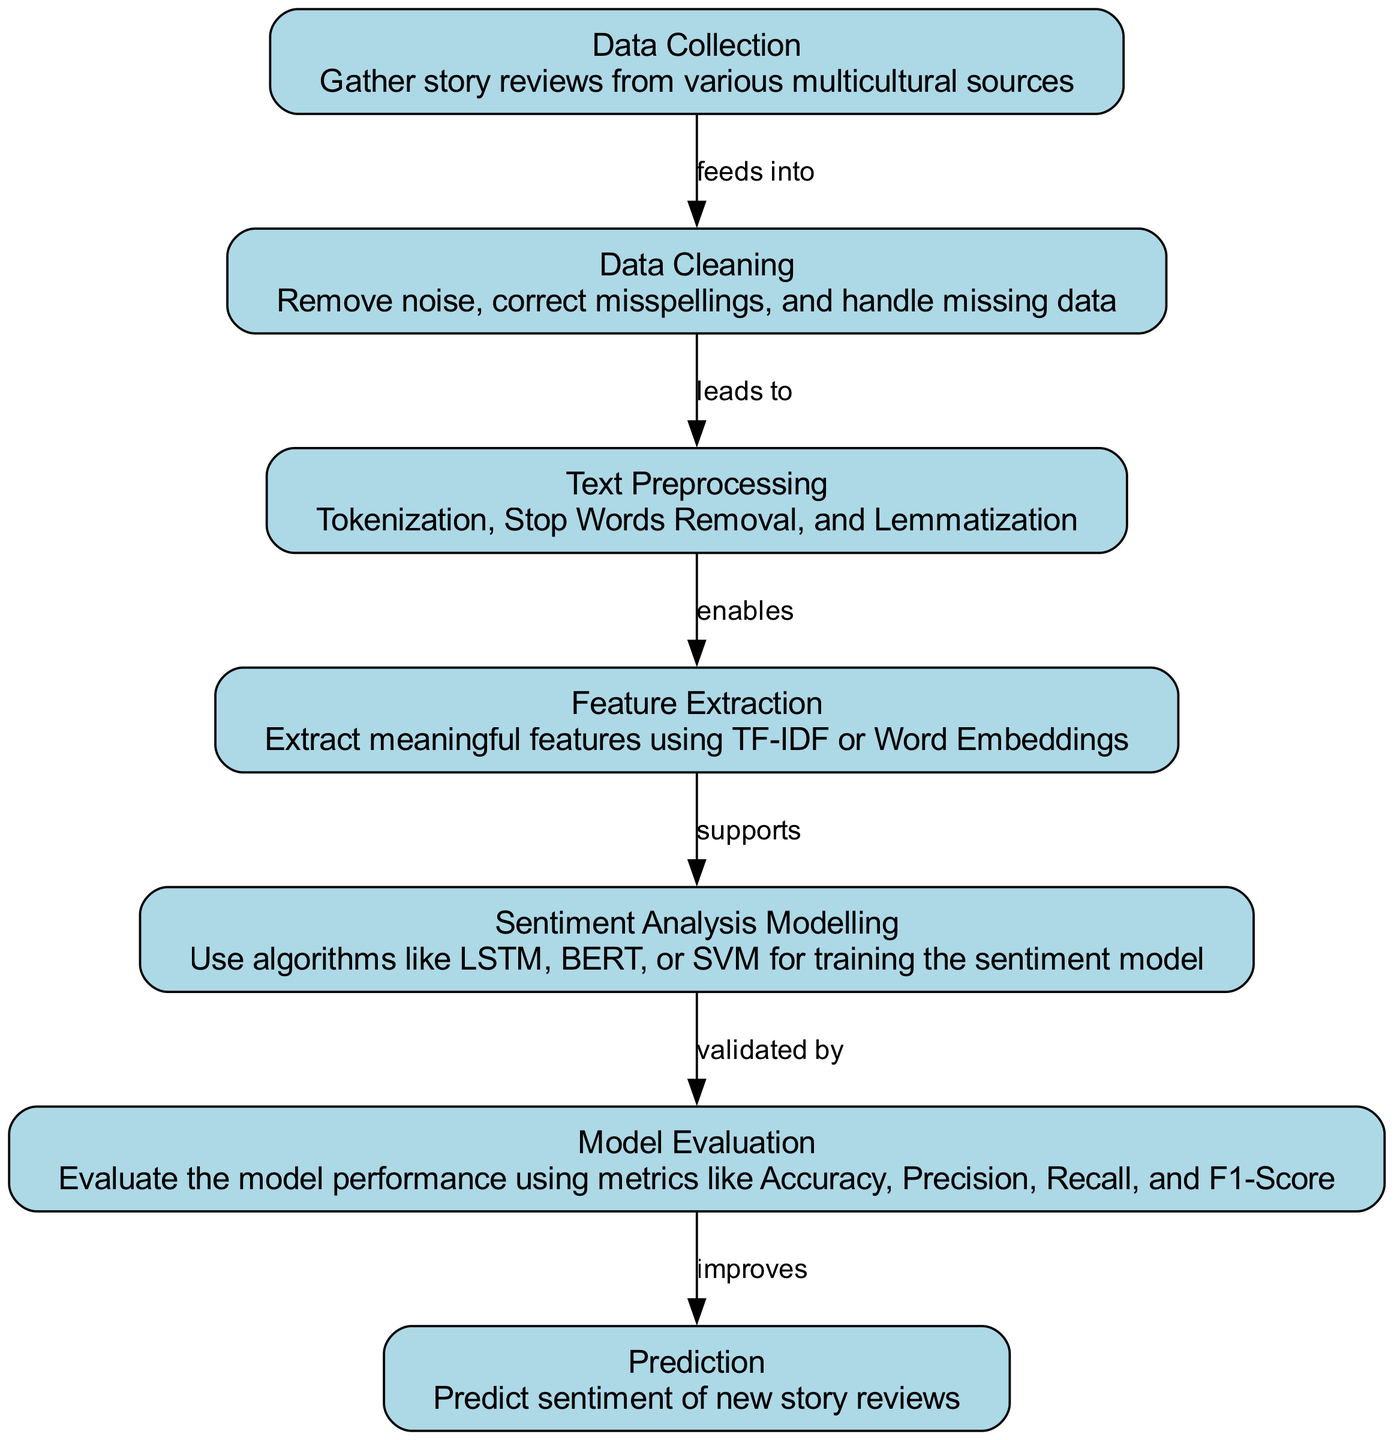What is the first step in the sentiment analysis process? The diagram indicates that the first node is 'Data Collection', which explains that it involves gathering story reviews from various multicultural sources.
Answer: Data Collection How many nodes are present in the diagram? By counting the listed nodes, there are a total of seven distinct nodes, each representing different steps in the process.
Answer: 7 What is the relationship between "Data Cleaning" and "Text Preprocessing"? The diagram shows an edge labeled 'leads to' from 'Data Cleaning' to 'Text Preprocessing', indicating that upon cleaning the data, the next step is to preprocess the text.
Answer: leads to What does "Feature Extraction" support? According to the edges in the diagram, 'Feature Extraction' supports 'Sentiment Analysis Modelling', meaning that the features extracted are necessary for building the sentiment analysis model.
Answer: Sentiment Analysis Modelling What metric is NOT mentioned for model evaluation in the diagram? The diagram lists Accuracy, Precision, Recall, and F1-Score as evaluation metrics, but it does not mention metrics like AUC or Log Loss, indicating alternatives not covered in this case.
Answer: AUC Describe the flow from "Sentiment Analysis Modelling" to "Prediction". After the 'Sentiment Analysis Modelling' step, which involves training the sentiment model, the diagram shows a flow to 'Prediction', where the trained model is then used to predict the sentiment of new story reviews.
Answer: improves Which step directly follows "Data Cleaning"? The diagram clearly indicates that 'Text Preprocessing' is the step that immediately follows 'Data Cleaning', reflecting the sequential order of operations in the process.
Answer: Text Preprocessing What is the purpose of "Model Evaluation"? The explanation in the diagram indicates that 'Model Evaluation' is for validating the model performance using various metrics, helping to quantify how well the model performs on the given data.
Answer: validate 